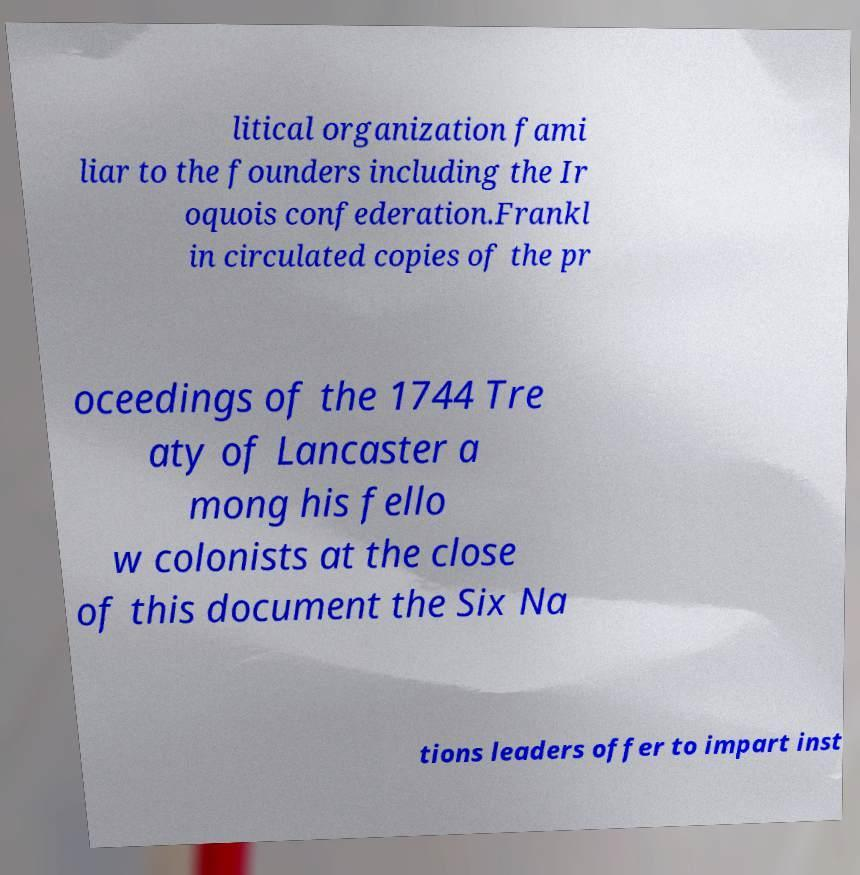Can you read and provide the text displayed in the image?This photo seems to have some interesting text. Can you extract and type it out for me? litical organization fami liar to the founders including the Ir oquois confederation.Frankl in circulated copies of the pr oceedings of the 1744 Tre aty of Lancaster a mong his fello w colonists at the close of this document the Six Na tions leaders offer to impart inst 